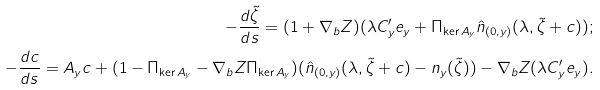Convert formula to latex. <formula><loc_0><loc_0><loc_500><loc_500>- \frac { d \tilde { \zeta } } { d s } = ( 1 + \nabla _ { b } Z ) ( \lambda C ^ { \prime } _ { y } { e } _ { y } + \Pi _ { \ker A _ { y } } \hat { n } _ { ( 0 , y ) } ( \lambda , \tilde { \zeta } + c ) ) ; \\ - \frac { d c } { d s } = A _ { y } c + ( 1 - \Pi _ { \ker A _ { y } } - \nabla _ { b } Z \Pi _ { \ker A _ { y } } ) ( \hat { n } _ { ( 0 , y ) } ( \lambda , \tilde { \zeta } + c ) - n _ { y } ( \tilde { \zeta } ) ) - \nabla _ { b } Z ( \lambda C ^ { \prime } _ { y } { e } _ { y } ) .</formula> 